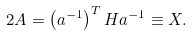Convert formula to latex. <formula><loc_0><loc_0><loc_500><loc_500>2 A = \left ( a ^ { - 1 } \right ) ^ { T } H a ^ { - 1 } \equiv X .</formula> 